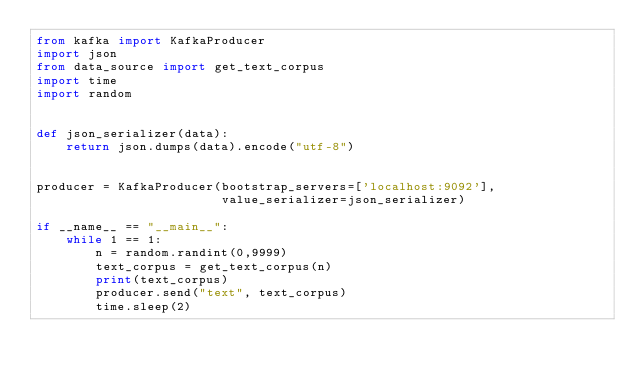Convert code to text. <code><loc_0><loc_0><loc_500><loc_500><_Python_>from kafka import KafkaProducer
import json
from data_source import get_text_corpus
import time
import random


def json_serializer(data):
    return json.dumps(data).encode("utf-8")


producer = KafkaProducer(bootstrap_servers=['localhost:9092'],
                         value_serializer=json_serializer)

if __name__ == "__main__":
    while 1 == 1:
        n = random.randint(0,9999)
        text_corpus = get_text_corpus(n)
        print(text_corpus)
        producer.send("text", text_corpus)
        time.sleep(2)</code> 